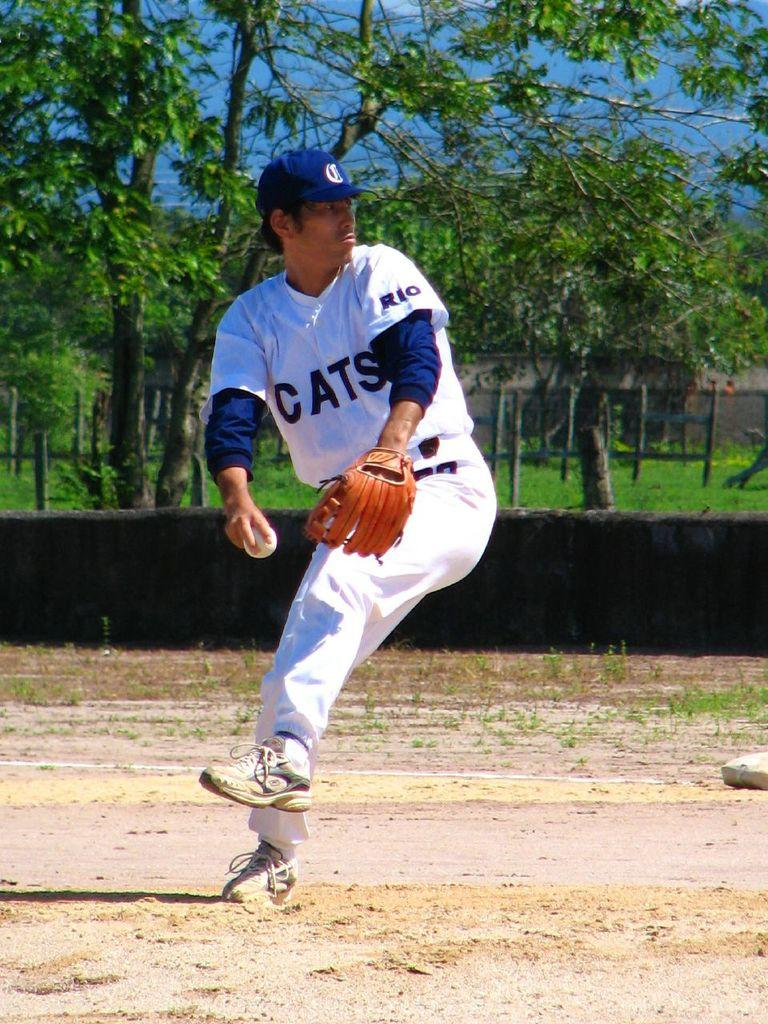Provide a one-sentence caption for the provided image. A man in a uniform with the team name Cats on it with a glove and baseball in hand. 